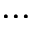<formula> <loc_0><loc_0><loc_500><loc_500>\dots</formula> 